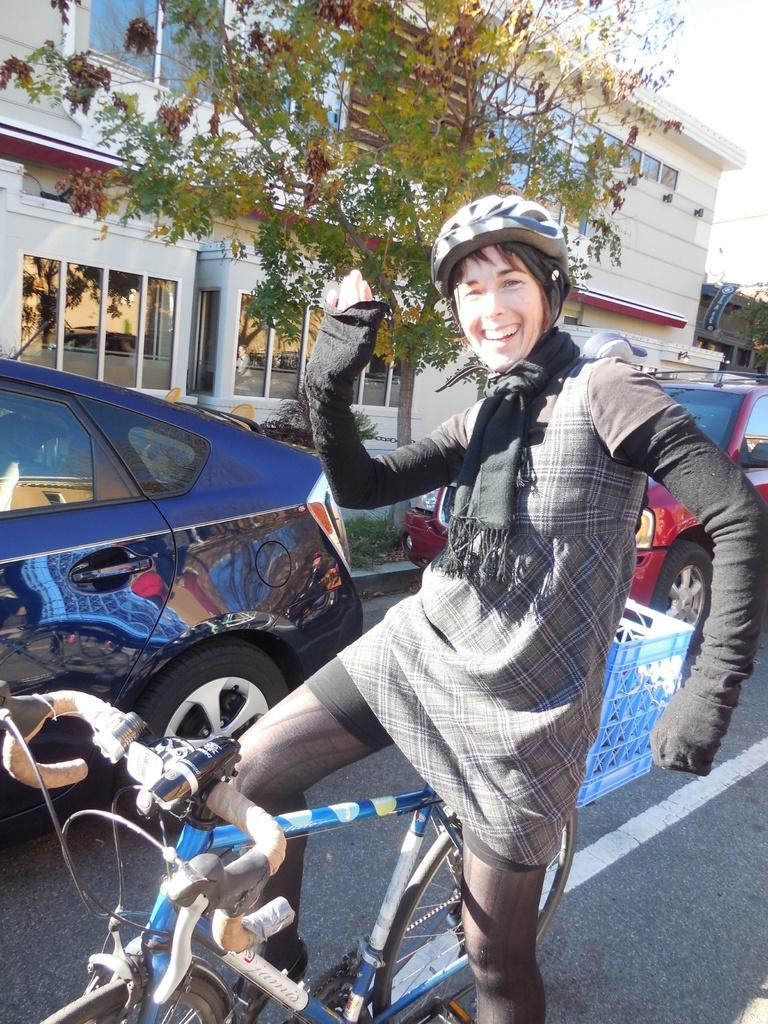What is the person in the image doing? There is a person sitting on a bicycle in the image. What else can be seen in the image besides the person on the bicycle? Motor vehicles and buildings are visible in the image. What type of natural vegetation is present in the image? There are trees in the image. What is visible at the top of the image? The sky is visible in the image. What type of spade is being used to dig a hole in the image? There is no spade present in the image. What type of plate is being used to serve food in the image? There is no plate present in the image. 